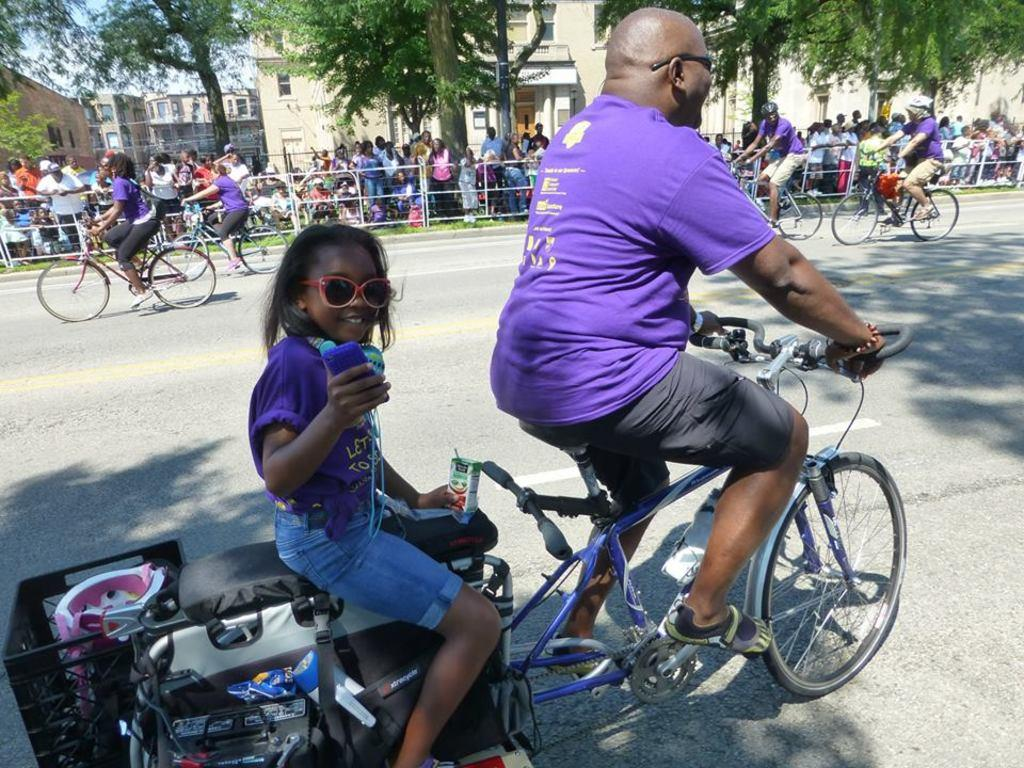What are the people in the image doing? The people in the image are cycling on the road. What are the people at the back side holding? The people at the back side are holding a metal rod. What can be seen in the background of the image? There are buildings, trees, and the sky visible in the background of the image. What type of haircut does the brother have in the image? There is no brother present in the image, and therefore no haircut can be observed. Is there a letter being delivered in the image? There is no indication of a letter or delivery in the image. 